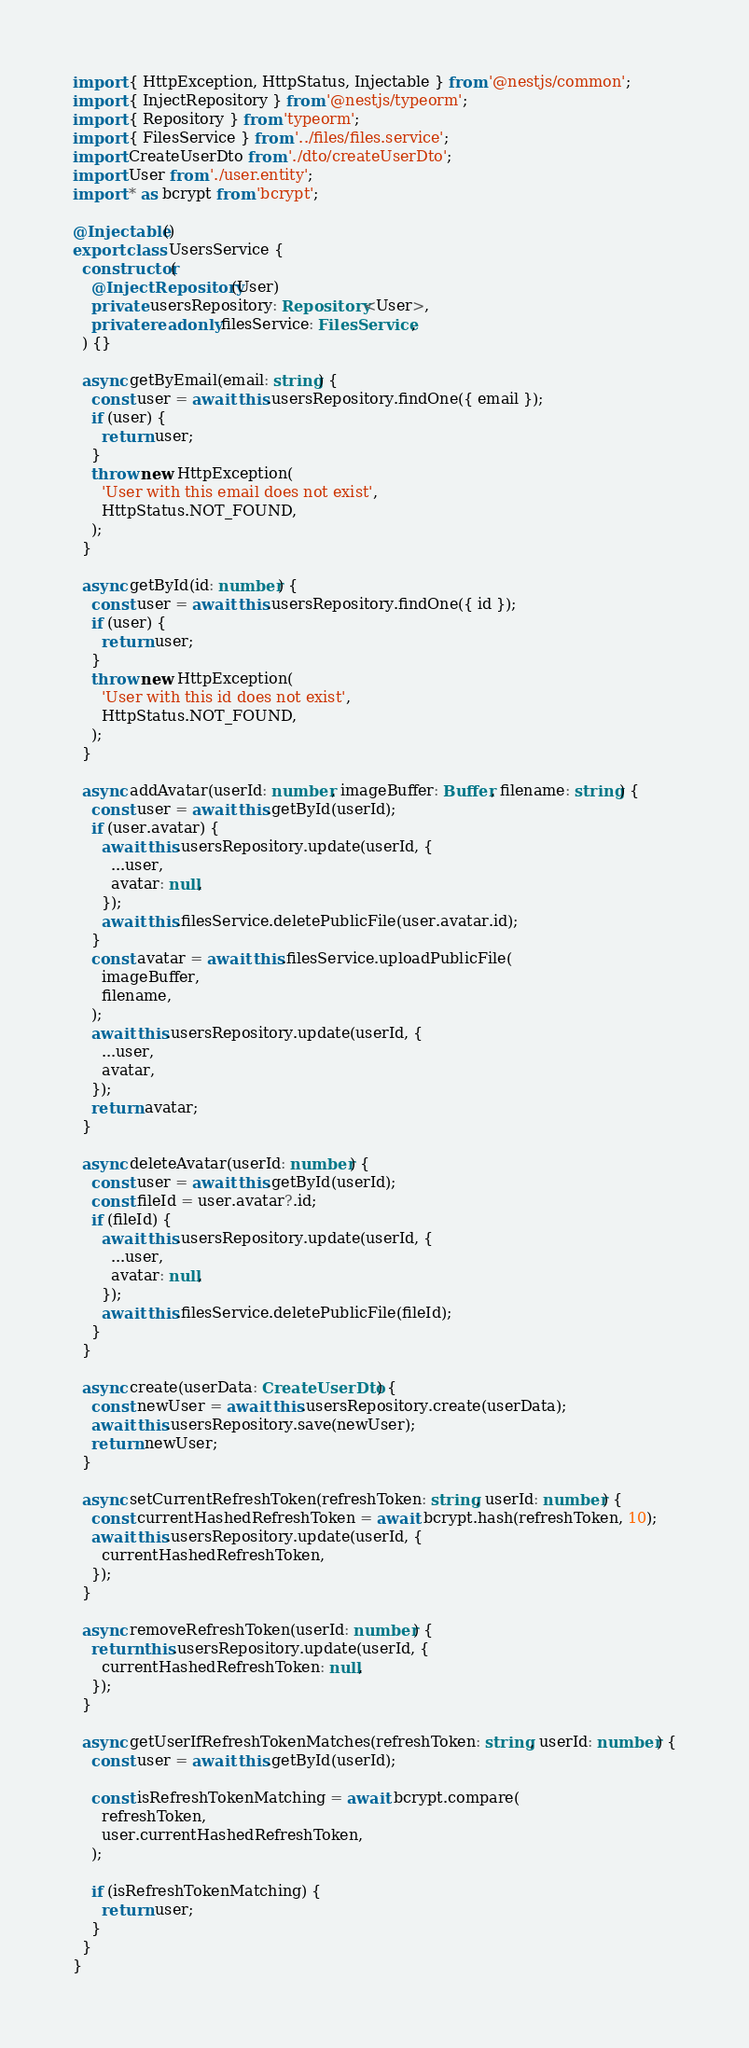Convert code to text. <code><loc_0><loc_0><loc_500><loc_500><_TypeScript_>import { HttpException, HttpStatus, Injectable } from '@nestjs/common';
import { InjectRepository } from '@nestjs/typeorm';
import { Repository } from 'typeorm';
import { FilesService } from '../files/files.service';
import CreateUserDto from './dto/createUserDto';
import User from './user.entity';
import * as bcrypt from 'bcrypt';

@Injectable()
export class UsersService {
  constructor(
    @InjectRepository(User)
    private usersRepository: Repository<User>,
    private readonly filesService: FilesService,
  ) {}

  async getByEmail(email: string) {
    const user = await this.usersRepository.findOne({ email });
    if (user) {
      return user;
    }
    throw new HttpException(
      'User with this email does not exist',
      HttpStatus.NOT_FOUND,
    );
  }

  async getById(id: number) {
    const user = await this.usersRepository.findOne({ id });
    if (user) {
      return user;
    }
    throw new HttpException(
      'User with this id does not exist',
      HttpStatus.NOT_FOUND,
    );
  }

  async addAvatar(userId: number, imageBuffer: Buffer, filename: string) {
    const user = await this.getById(userId);
    if (user.avatar) {
      await this.usersRepository.update(userId, {
        ...user,
        avatar: null,
      });
      await this.filesService.deletePublicFile(user.avatar.id);
    }
    const avatar = await this.filesService.uploadPublicFile(
      imageBuffer,
      filename,
    );
    await this.usersRepository.update(userId, {
      ...user,
      avatar,
    });
    return avatar;
  }

  async deleteAvatar(userId: number) {
    const user = await this.getById(userId);
    const fileId = user.avatar?.id;
    if (fileId) {
      await this.usersRepository.update(userId, {
        ...user,
        avatar: null,
      });
      await this.filesService.deletePublicFile(fileId);
    }
  }

  async create(userData: CreateUserDto) {
    const newUser = await this.usersRepository.create(userData);
    await this.usersRepository.save(newUser);
    return newUser;
  }

  async setCurrentRefreshToken(refreshToken: string, userId: number) {
    const currentHashedRefreshToken = await bcrypt.hash(refreshToken, 10);
    await this.usersRepository.update(userId, {
      currentHashedRefreshToken,
    });
  }

  async removeRefreshToken(userId: number) {
    return this.usersRepository.update(userId, {
      currentHashedRefreshToken: null,
    });
  }

  async getUserIfRefreshTokenMatches(refreshToken: string, userId: number) {
    const user = await this.getById(userId);

    const isRefreshTokenMatching = await bcrypt.compare(
      refreshToken,
      user.currentHashedRefreshToken,
    );

    if (isRefreshTokenMatching) {
      return user;
    }
  }
}
</code> 